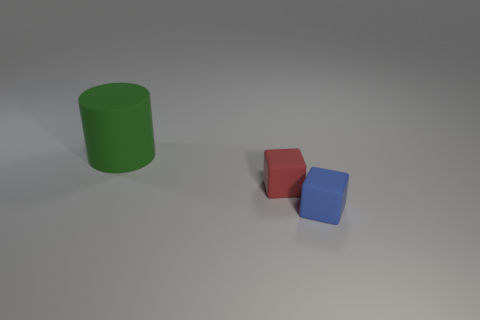There is a cube behind the rubber cube in front of the tiny red thing; what is it made of?
Ensure brevity in your answer.  Rubber. What number of tiny red matte objects are the same shape as the blue matte object?
Keep it short and to the point. 1. The green rubber thing has what shape?
Provide a succinct answer. Cylinder. Is the number of tiny gray metal spheres less than the number of large green matte objects?
Provide a succinct answer. Yes. Are there any other things that are the same size as the blue matte thing?
Keep it short and to the point. Yes. What material is the blue object that is the same shape as the tiny red thing?
Your answer should be very brief. Rubber. Are there more blue objects than yellow rubber spheres?
Keep it short and to the point. Yes. What number of other things are there of the same color as the large thing?
Your answer should be very brief. 0. Is the material of the blue object the same as the object to the left of the red thing?
Offer a very short reply. Yes. What number of blue matte cubes are on the right side of the rubber thing on the right side of the tiny object on the left side of the small blue matte cube?
Your response must be concise. 0. 